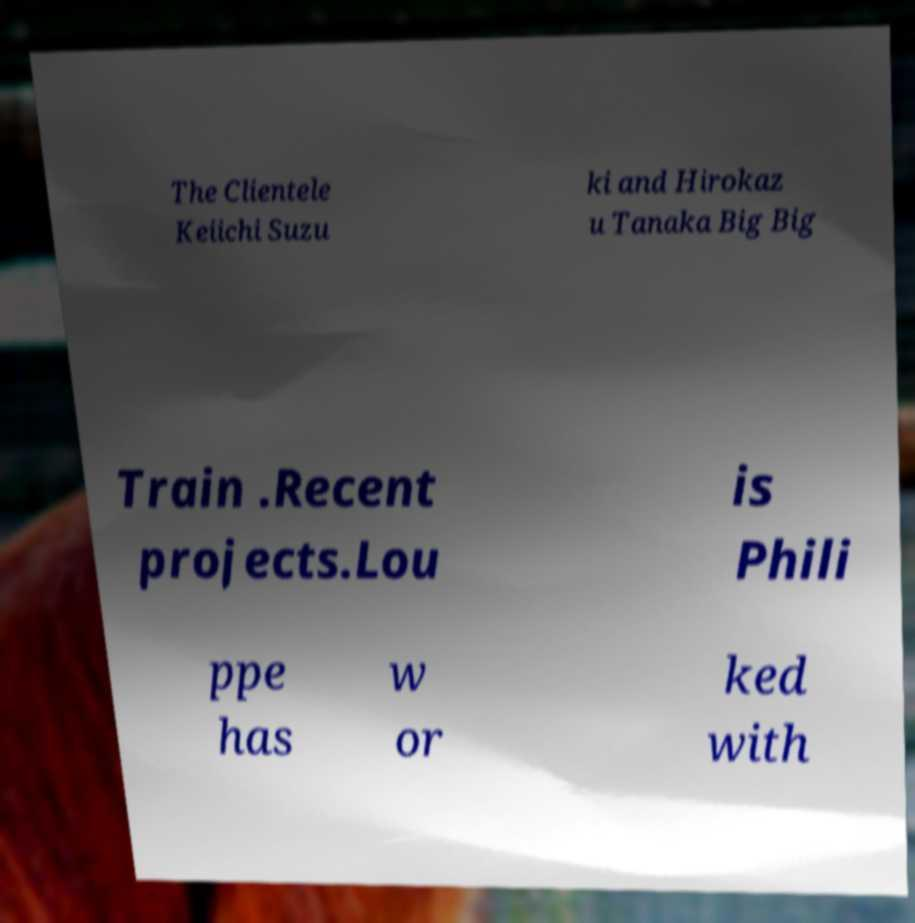What messages or text are displayed in this image? I need them in a readable, typed format. The Clientele Keiichi Suzu ki and Hirokaz u Tanaka Big Big Train .Recent projects.Lou is Phili ppe has w or ked with 